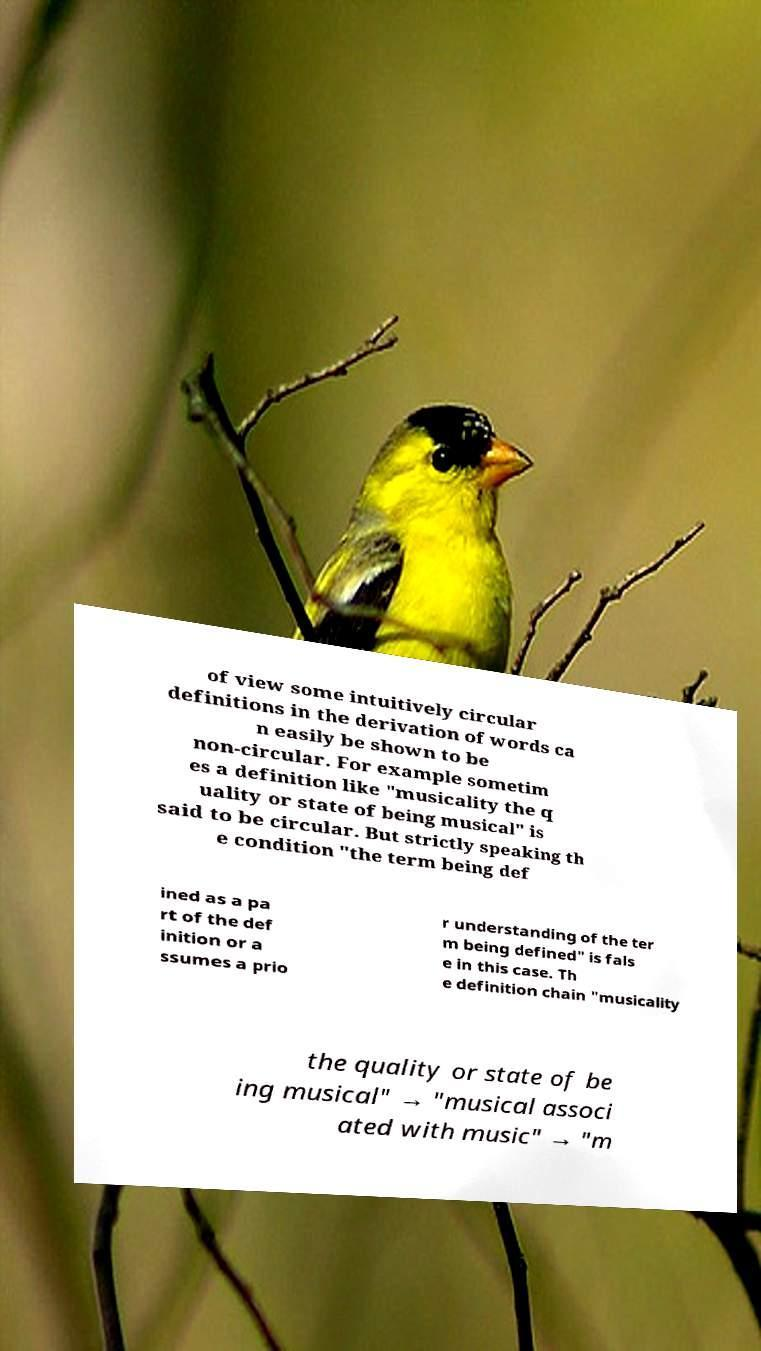Please identify and transcribe the text found in this image. of view some intuitively circular definitions in the derivation of words ca n easily be shown to be non-circular. For example sometim es a definition like "musicality the q uality or state of being musical" is said to be circular. But strictly speaking th e condition "the term being def ined as a pa rt of the def inition or a ssumes a prio r understanding of the ter m being defined" is fals e in this case. Th e definition chain "musicality the quality or state of be ing musical" → "musical associ ated with music" → "m 